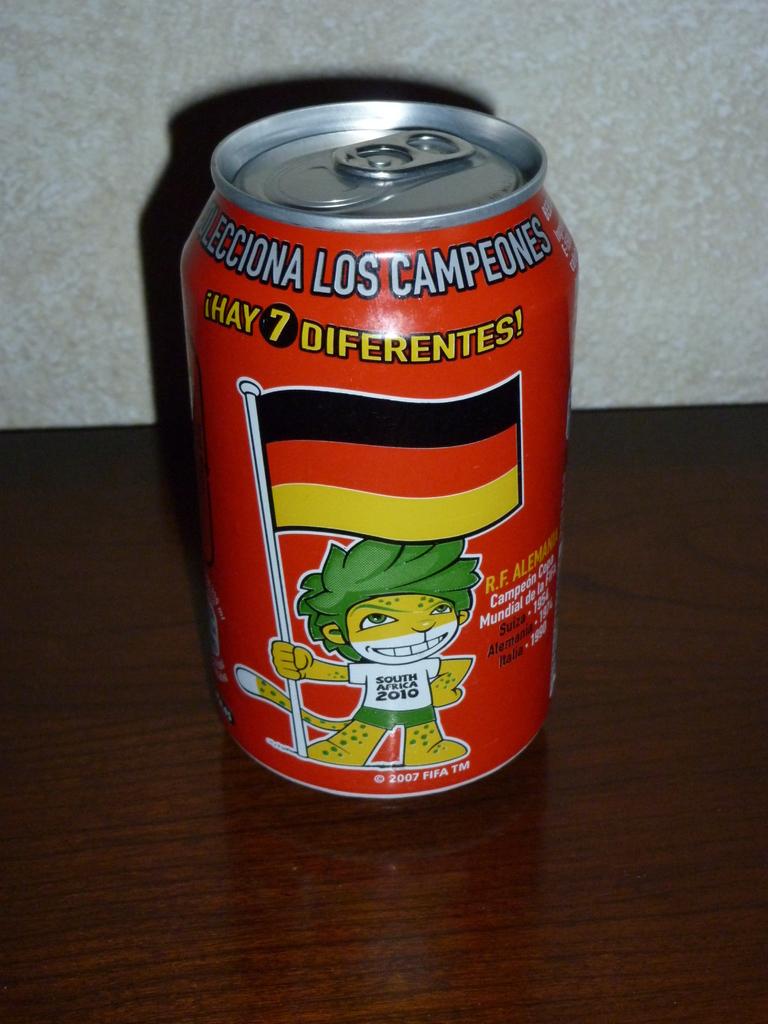What number is shown on the can?
Your answer should be very brief. 7. 